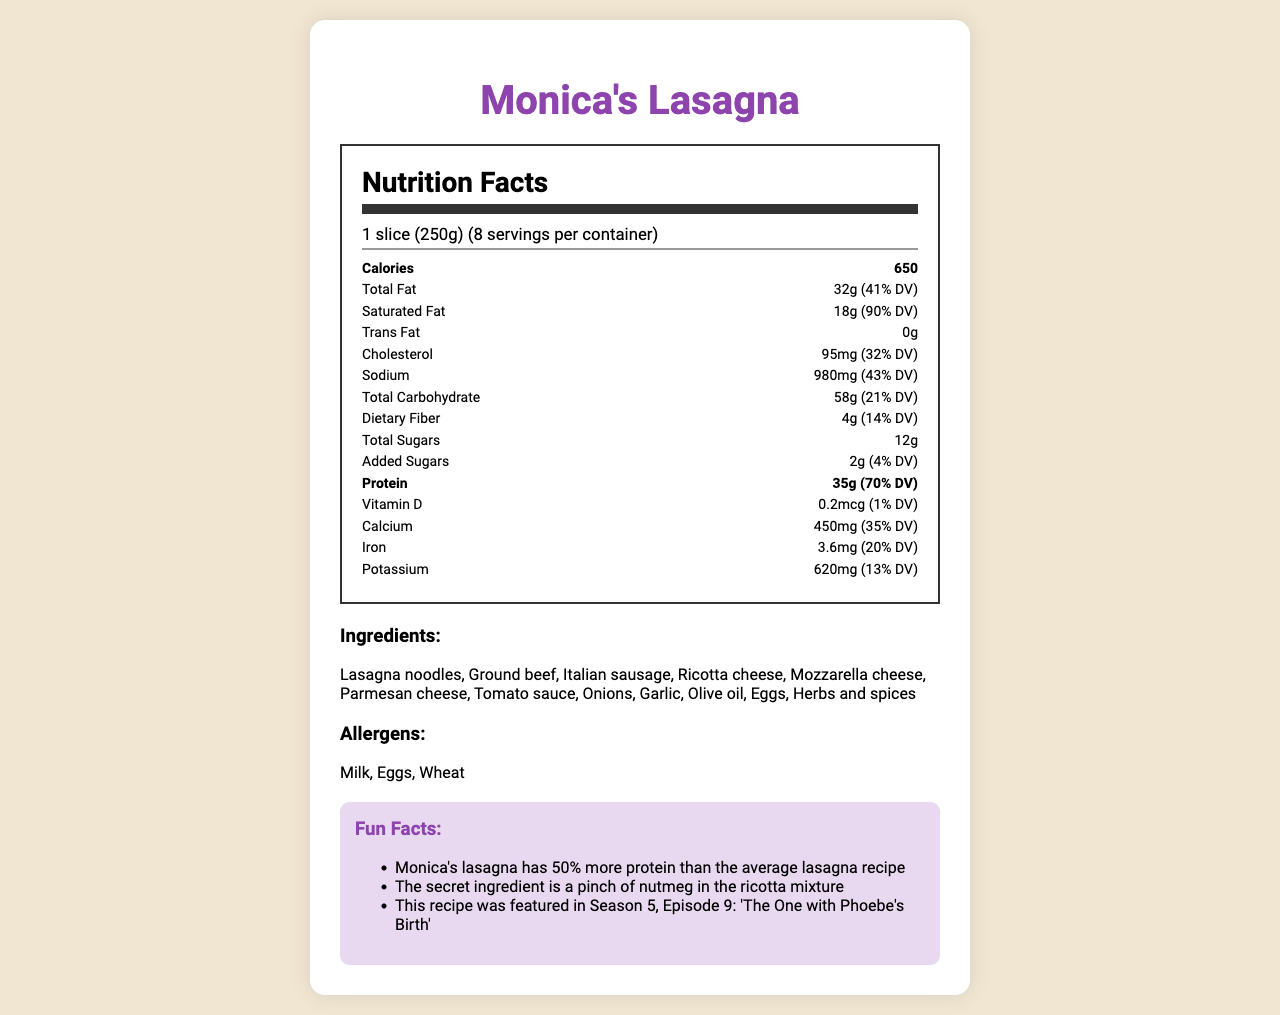how many calories are in one serving of Monica's Lasagna? The nutrition label shows that there are 650 calories per serving.
Answer: 650 how many servings are in a container of Monica's Lasagna? The document states that there are 8 servings per container.
Answer: 8 how much protein is in one serving? The protein content per serving is listed as 35g.
Answer: 35g how much saturated fat does Monica's Lasagna contain per serving? The nutrition label specifies that there are 18g of saturated fat per serving.
Answer: 18g what is the percentage of daily value for sodium per serving? The sodium daily value percentage is listed as 43%.
Answer: 43% which of the following is an allergen in Monica's Lasagna? 
A. Soy
B. Eggs
C. Peanuts The allergens listed include Milk, Eggs, and Wheat, with Eggs being the correct answer.
Answer: B how much iron does one serving provide compared to the daily value? 
I. 10%
II. 20%
III. 30%
IV. 40% One serving provides 20% of the daily value of iron.
Answer: II is there any trans fat in Monica's Lasagna? The document states that the trans fat content is 0g.
Answer: No summarize the main idea of the document. The document details essential nutritional information about Monica's Lasagna, covering calories, fats, cholesterol, sodium, carbohydrates, protein, vitamins, and minerals per serving. It also includes a list of ingredients, allergens, and fun facts.
Answer: The document provides comprehensive nutritional information for Monica's Lasagna, including calorie content, macronutrient and micronutrient values, ingredients, allergens, and some fun facts about the dish. what is the secret ingredient Monica uses in her lasagna? The document hints that there is a secret ingredient but does not specify what it is.
Answer: Not enough information how much dietary fiber is in one serving of Monica's Lasagna? The label shows that each serving contains 4g of dietary fiber.
Answer: 4g what is the amount of calcium provided per serving compared to the daily value? The daily value percentage for calcium per serving is 35%.
Answer: 35% which ingredient is not listed in Monica's Lasagna? 
A. Onions
B. Bell Peppers
C. Garlic The ingredients section lists Onions and Garlic but not Bell Peppers.
Answer: B is Monica's Lasagna featured in any specific episode of the show? The fun facts mention that Monica's Lasagna was featured in Season 5, Episode 9: 'The One with Phoebe's Birth'.
Answer: Yes 